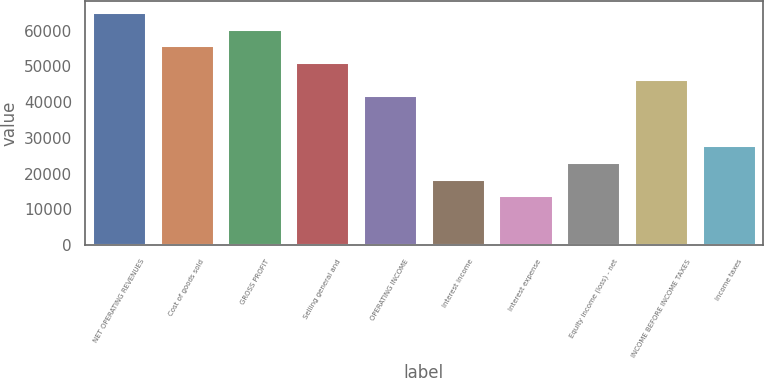Convert chart. <chart><loc_0><loc_0><loc_500><loc_500><bar_chart><fcel>NET OPERATING REVENUES<fcel>Cost of goods sold<fcel>GROSS PROFIT<fcel>Selling general and<fcel>OPERATING INCOME<fcel>Interest income<fcel>Interest expense<fcel>Equity income (loss) - net<fcel>INCOME BEFORE INCOME TAXES<fcel>Income taxes<nl><fcel>65157.3<fcel>55849.7<fcel>60503.5<fcel>51195.8<fcel>41888.2<fcel>18619<fcel>13965.2<fcel>23272.8<fcel>46542<fcel>27926.7<nl></chart> 